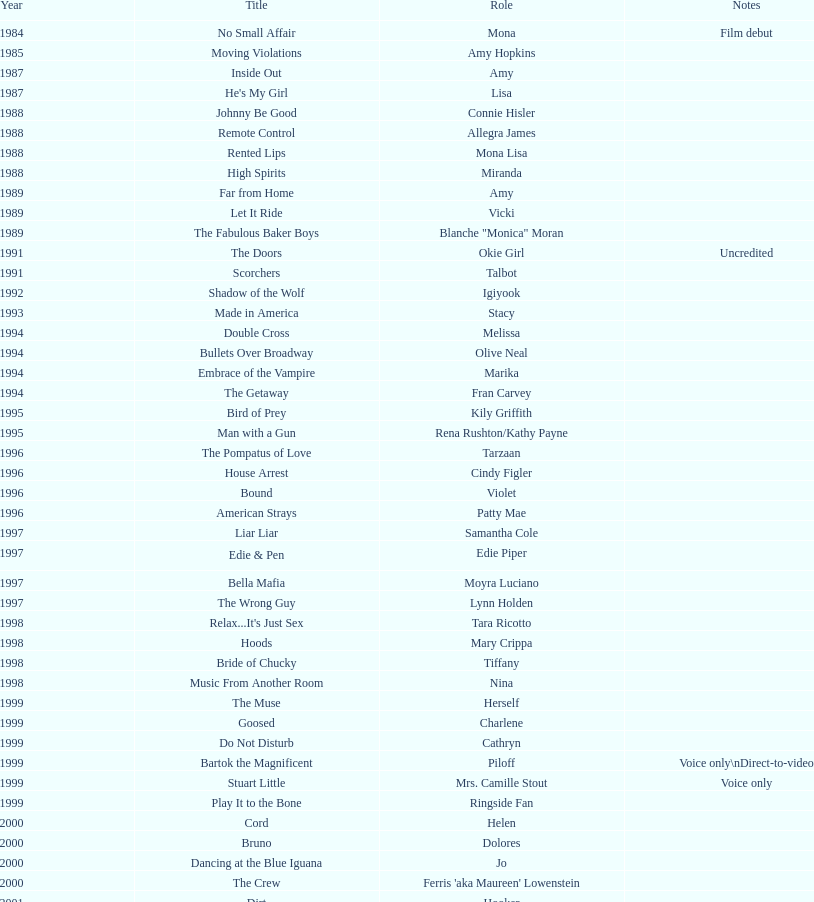In which movie did someone make their film debut? No Small Affair. 